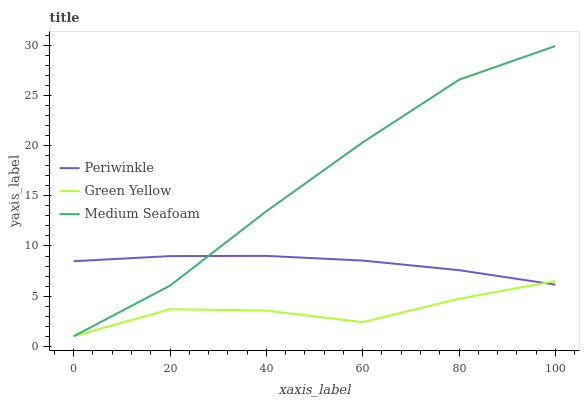Does Green Yellow have the minimum area under the curve?
Answer yes or no. Yes. Does Medium Seafoam have the maximum area under the curve?
Answer yes or no. Yes. Does Periwinkle have the minimum area under the curve?
Answer yes or no. No. Does Periwinkle have the maximum area under the curve?
Answer yes or no. No. Is Periwinkle the smoothest?
Answer yes or no. Yes. Is Green Yellow the roughest?
Answer yes or no. Yes. Is Medium Seafoam the smoothest?
Answer yes or no. No. Is Medium Seafoam the roughest?
Answer yes or no. No. Does Green Yellow have the lowest value?
Answer yes or no. Yes. Does Periwinkle have the lowest value?
Answer yes or no. No. Does Medium Seafoam have the highest value?
Answer yes or no. Yes. Does Periwinkle have the highest value?
Answer yes or no. No. Does Green Yellow intersect Periwinkle?
Answer yes or no. Yes. Is Green Yellow less than Periwinkle?
Answer yes or no. No. Is Green Yellow greater than Periwinkle?
Answer yes or no. No. 